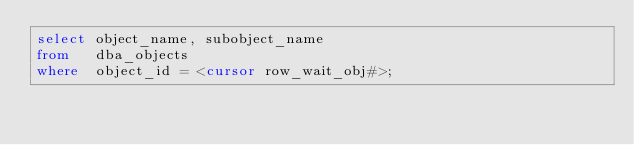Convert code to text. <code><loc_0><loc_0><loc_500><loc_500><_SQL_>select object_name, subobject_name
from   dba_objects 
where  object_id = <cursor row_wait_obj#>;





</code> 